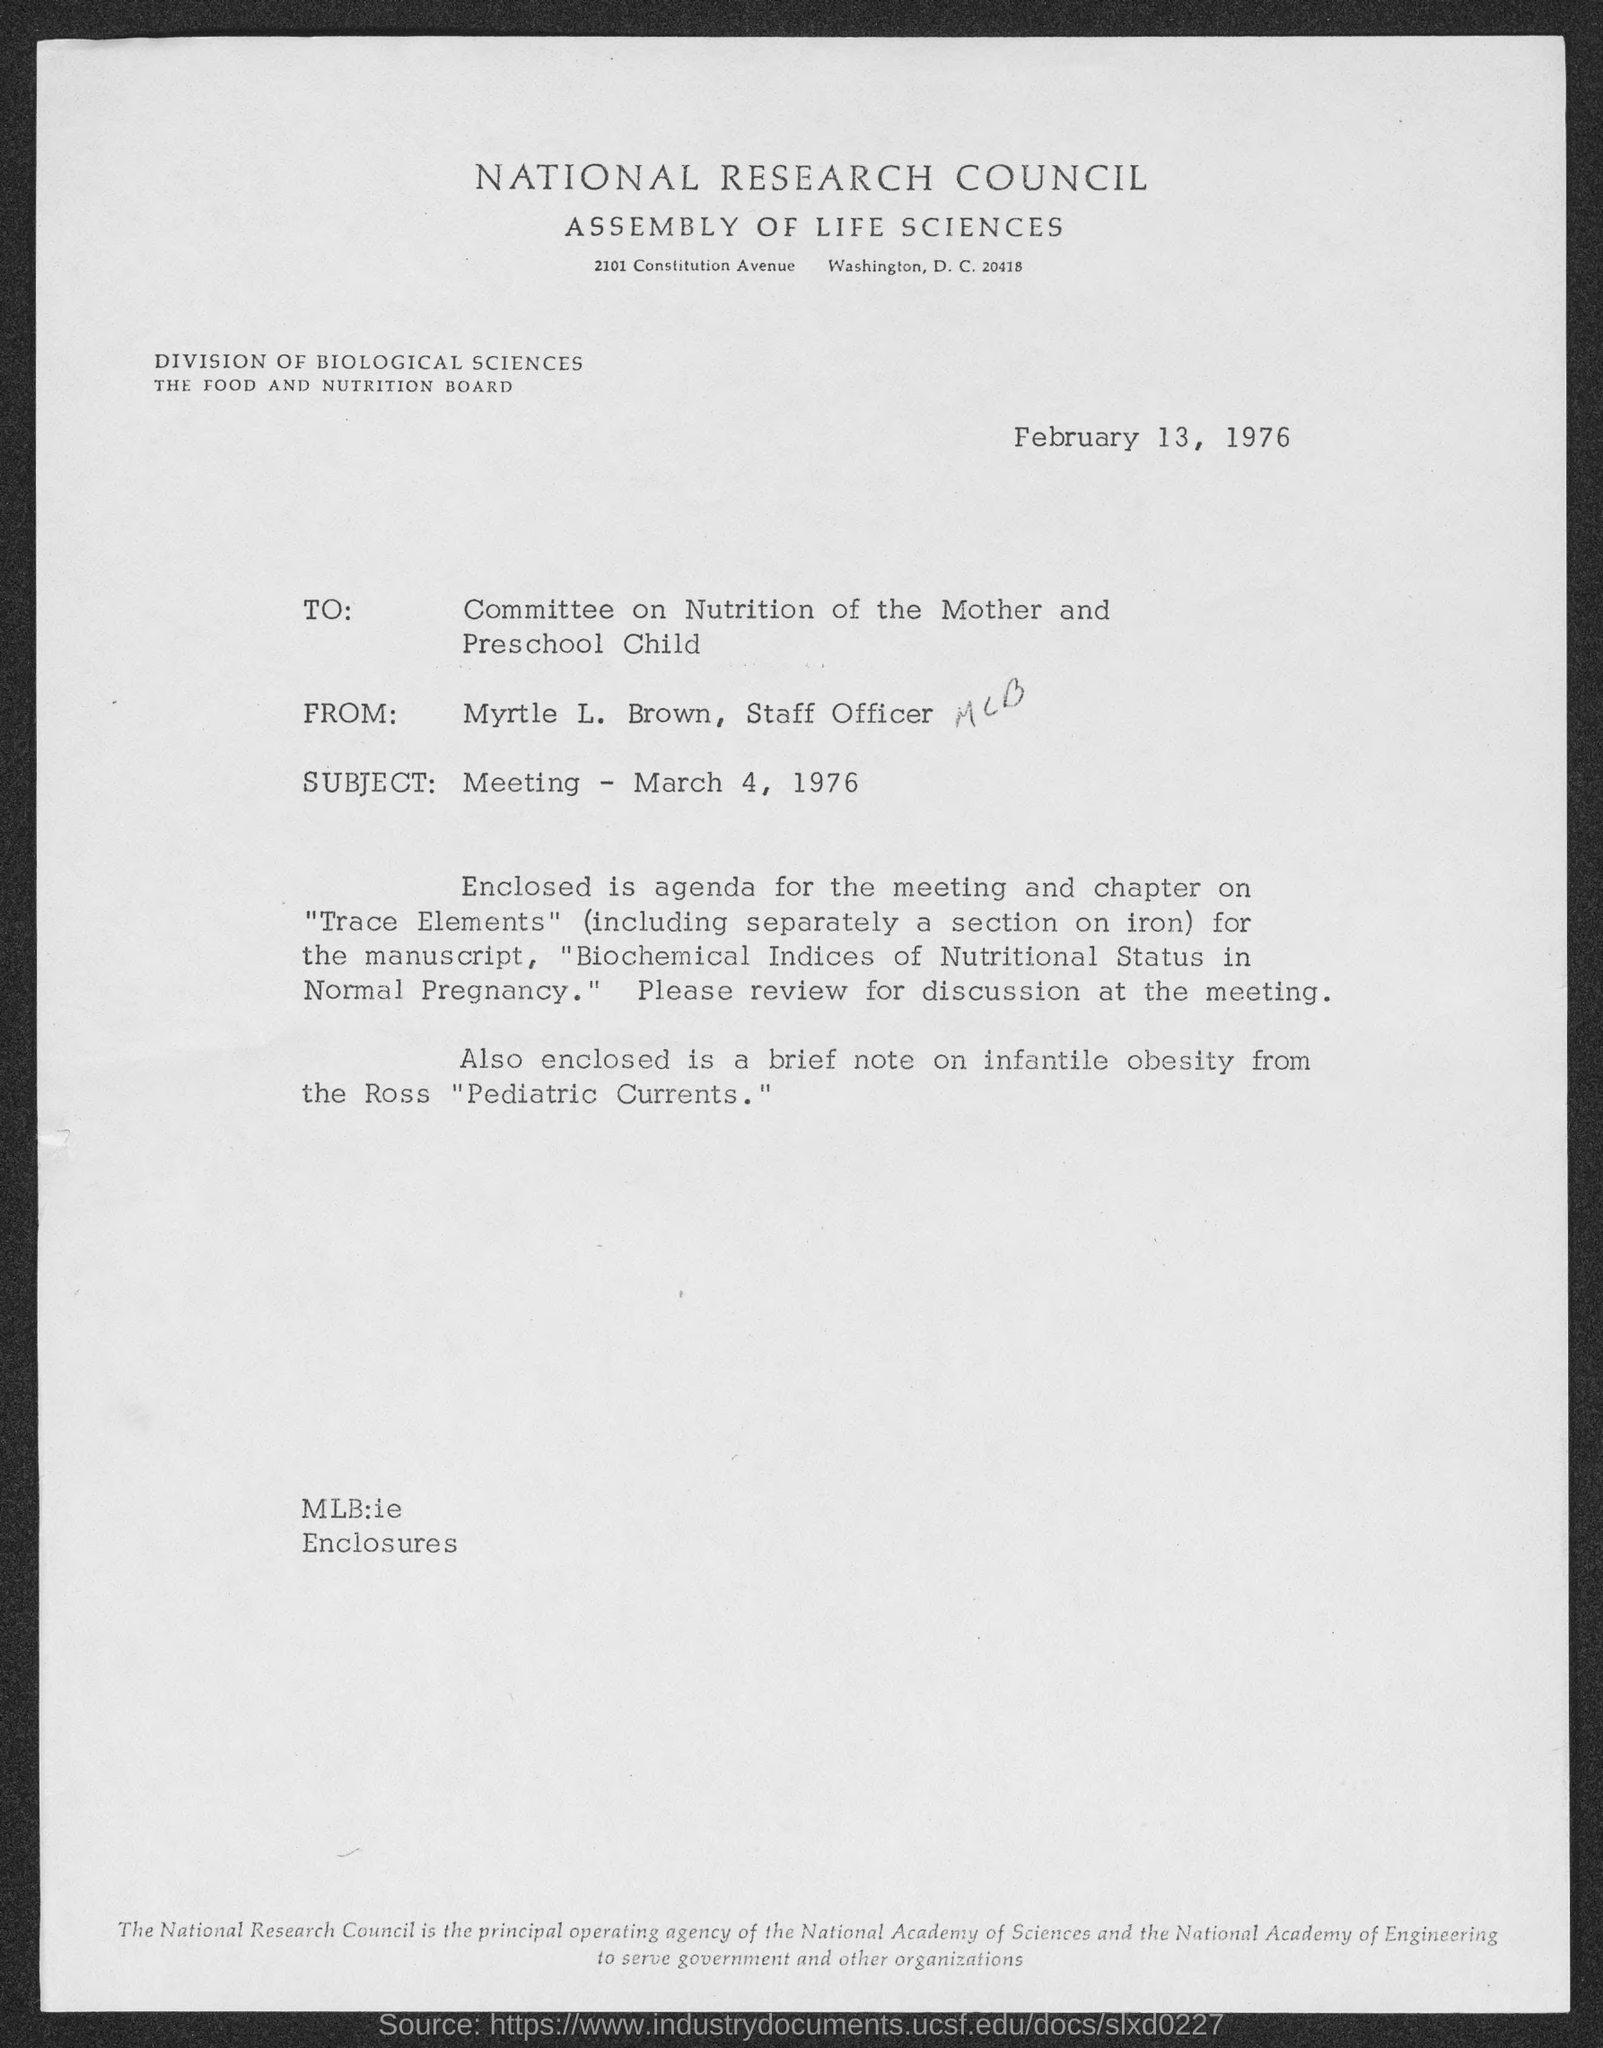Give some essential details in this illustration. The letterhead mentions the National Research Council. The letter is addressed to the Committee on Nutrition of the Mother and Preschool Child. The subject mentioned in the letter is the meeting that took place on March 4, 1976. The letter is from Myrtle L. Brown, who is a staff officer. The letter states that the date mentioned in it is February 13, 1976. 